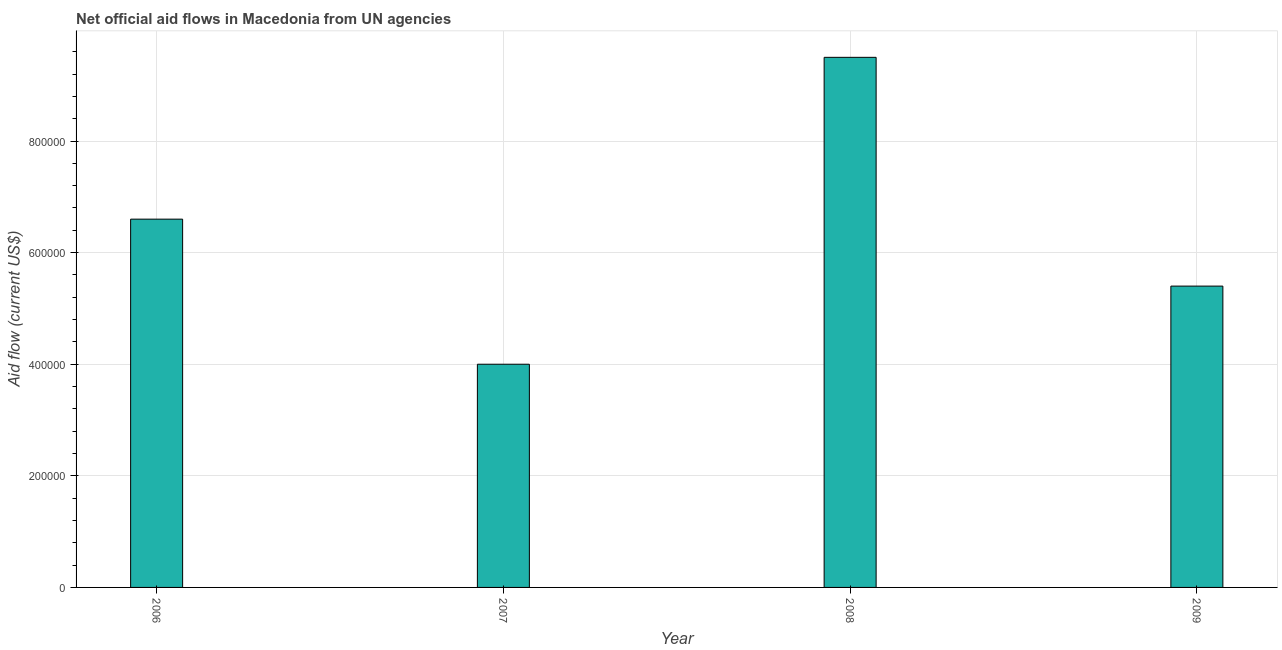Does the graph contain grids?
Make the answer very short. Yes. What is the title of the graph?
Your answer should be very brief. Net official aid flows in Macedonia from UN agencies. What is the label or title of the X-axis?
Make the answer very short. Year. What is the label or title of the Y-axis?
Your answer should be compact. Aid flow (current US$). Across all years, what is the maximum net official flows from un agencies?
Keep it short and to the point. 9.50e+05. Across all years, what is the minimum net official flows from un agencies?
Offer a terse response. 4.00e+05. In which year was the net official flows from un agencies minimum?
Offer a terse response. 2007. What is the sum of the net official flows from un agencies?
Your answer should be compact. 2.55e+06. What is the average net official flows from un agencies per year?
Make the answer very short. 6.38e+05. Do a majority of the years between 2008 and 2006 (inclusive) have net official flows from un agencies greater than 600000 US$?
Give a very brief answer. Yes. What is the ratio of the net official flows from un agencies in 2007 to that in 2009?
Offer a very short reply. 0.74. Is the difference between the net official flows from un agencies in 2008 and 2009 greater than the difference between any two years?
Provide a succinct answer. No. What is the difference between the highest and the second highest net official flows from un agencies?
Give a very brief answer. 2.90e+05. What is the difference between the highest and the lowest net official flows from un agencies?
Provide a succinct answer. 5.50e+05. How many bars are there?
Your answer should be very brief. 4. Are all the bars in the graph horizontal?
Provide a succinct answer. No. How many years are there in the graph?
Offer a very short reply. 4. What is the Aid flow (current US$) in 2006?
Provide a succinct answer. 6.60e+05. What is the Aid flow (current US$) of 2008?
Provide a succinct answer. 9.50e+05. What is the Aid flow (current US$) of 2009?
Keep it short and to the point. 5.40e+05. What is the difference between the Aid flow (current US$) in 2006 and 2008?
Your response must be concise. -2.90e+05. What is the difference between the Aid flow (current US$) in 2007 and 2008?
Your answer should be compact. -5.50e+05. What is the difference between the Aid flow (current US$) in 2007 and 2009?
Keep it short and to the point. -1.40e+05. What is the ratio of the Aid flow (current US$) in 2006 to that in 2007?
Your response must be concise. 1.65. What is the ratio of the Aid flow (current US$) in 2006 to that in 2008?
Make the answer very short. 0.69. What is the ratio of the Aid flow (current US$) in 2006 to that in 2009?
Ensure brevity in your answer.  1.22. What is the ratio of the Aid flow (current US$) in 2007 to that in 2008?
Offer a terse response. 0.42. What is the ratio of the Aid flow (current US$) in 2007 to that in 2009?
Your answer should be very brief. 0.74. What is the ratio of the Aid flow (current US$) in 2008 to that in 2009?
Make the answer very short. 1.76. 